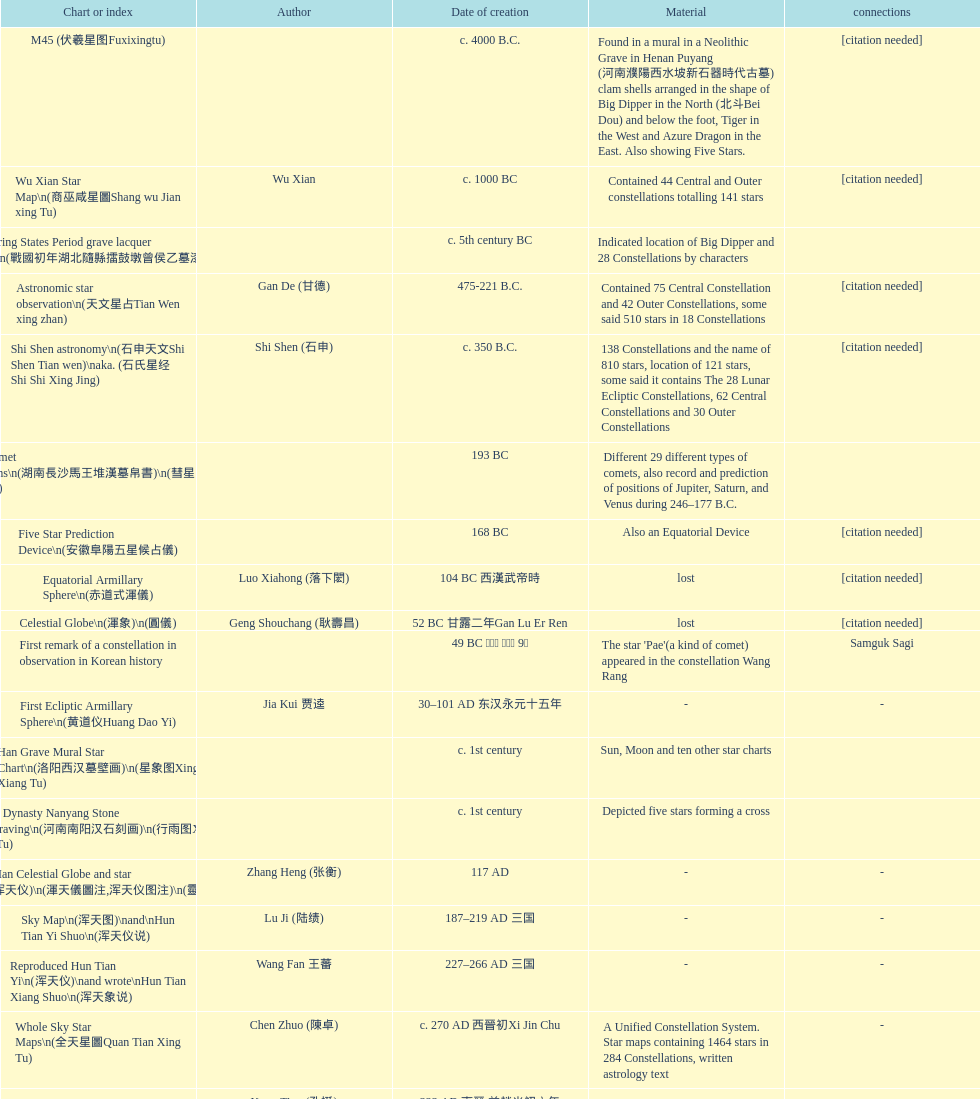Name three items created not long after the equatorial armillary sphere. Celestial Globe (渾象) (圓儀), First remark of a constellation in observation in Korean history, First Ecliptic Armillary Sphere (黄道仪Huang Dao Yi). 